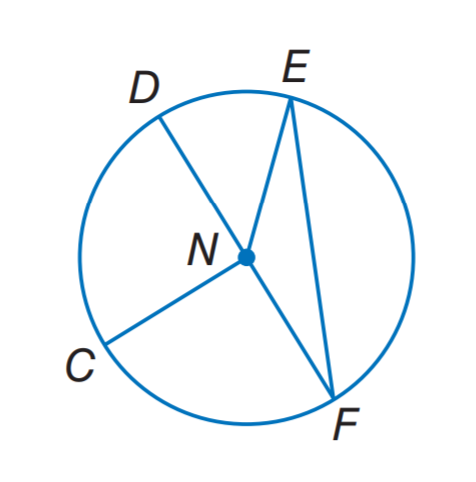Answer the mathemtical geometry problem and directly provide the correct option letter.
Question: If E N = 13, what is the diameter of the circle?
Choices: A: 6.5 B: 13 C: 19.5 D: 26 D 